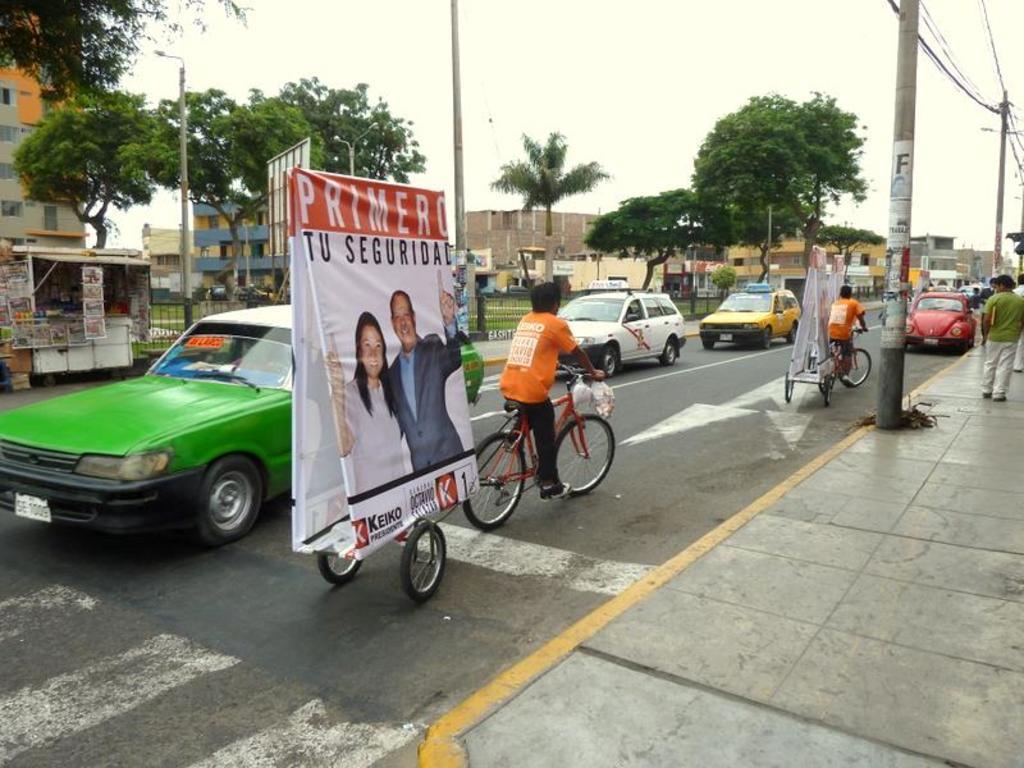Can you describe this image briefly? In this picture we can see there are two persons riding bicycles and to the bicycles there are carts. On the carts there are banners. On the road there are some vehicles. On the right side of the image, there are people and electric poles with cables. Behind the vehicles there are poles, iron grilles, a shop, trees, buildings and the sky. 